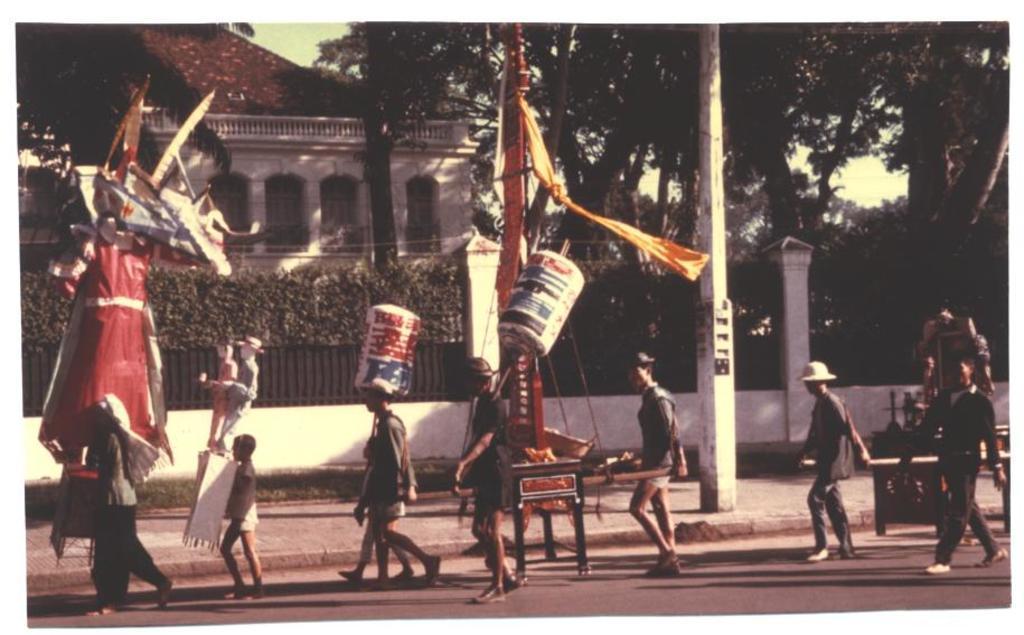Could you give a brief overview of what you see in this image? In this image I can see group of people walking on the road. Background I can see few poles, building in white color, trees in green color and sky is in white color. 